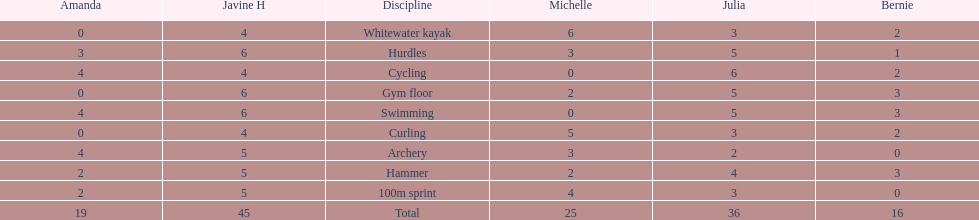Who had her best score in cycling? Julia. 